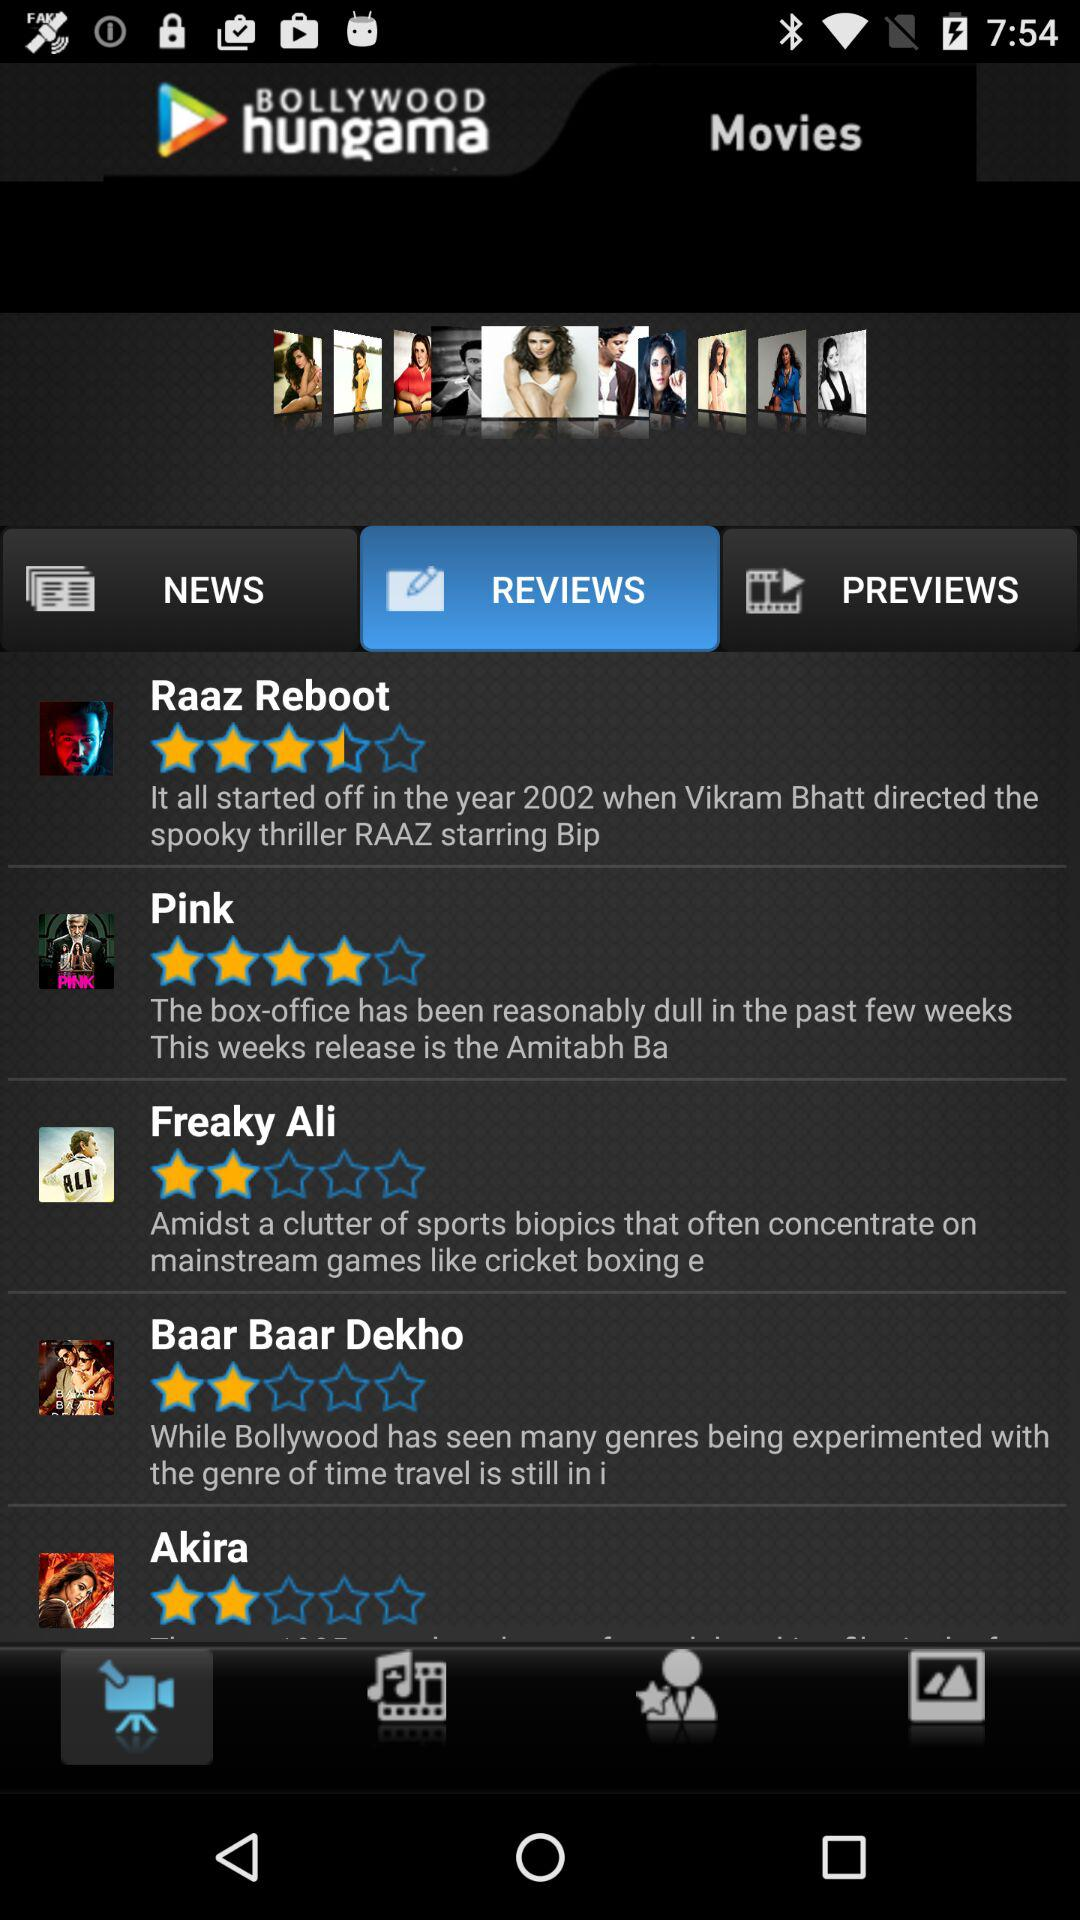What is the rating of "Pink"? The rating is 4 stars. 